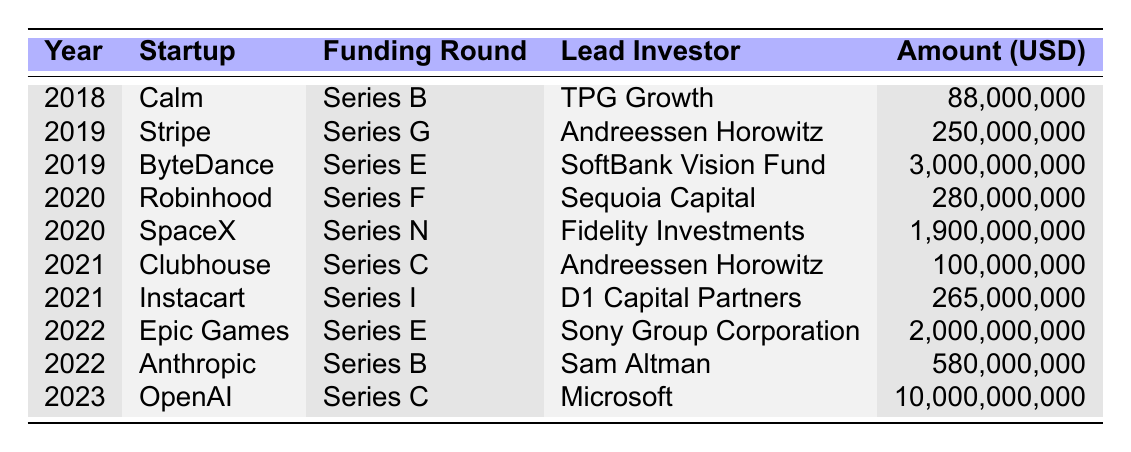What was the total funding amount raised by Stripe? According to the table, Stripe raised a total of $250,000,000 in its Series G funding round in 2019.
Answer: 250000000 Which startup received the highest funding amount? Looking at the table, OpenAI received the highest funding amount of $10,000,000,000 in its Series C round in 2023.
Answer: 10000000000 How many startups were funded in 2020? The table shows that Robinhood and SpaceX were funded in 2020, which makes a total of 2 startups.
Answer: 2 What is the average funding amount for the startups listed in 2019? The funding amounts for startups in 2019 are $250,000,000 (Stripe) and $3,000,000,000 (ByteDance). The total is $3,250,000,000, and with 2 startups, the average is $3,250,000,000 / 2 = $1,625,000,000.
Answer: 1625000000 Did Andreessen Horowitz invest in any startups in 2021? Yes, Andreessen Horowitz was the lead investor for Clubhouse in 2021, according to the table.
Answer: Yes How much more funding did SpaceX receive compared to Robinhood? SpaceX received $1,900,000,000, while Robinhood received $280,000,000. The difference is $1,900,000,000 - $280,000,000 = $1,620,000,000.
Answer: 1620000000 What percentage of the total funding received by Calm and Anthropic combined comes from Calm? Calm received $88,000,000 and Anthropic received $580,000,000. The combined funding is $88,000,000 + $580,000,000 = $668,000,000. The percentage from Calm is ($88,000,000 / $668,000,000) * 100 ≈ 13.16%.
Answer: 13.16 Which lead investor participated in the most funding rounds? The table shows that Andreessen Horowitz invested in two startups: Stripe and Clubhouse. Other investors each participated in only one. Thus, Andreessen Horowitz has the most participation.
Answer: Andreessen Horowitz How much funding was raised in 2022 compared to 2021? In 2022, Epic Games raised $2,000,000,000 and Anthropic raised $580,000,000, totaling $2,580,000,000. In 2021, Clubhouse raised $100,000,000 and Instacart raised $265,000,000, totaling $365,000,000. The difference is $2,580,000,000 - $365,000,000 = $2,215,000,000 raised in 2022 compared to 2021.
Answer: 2215000000 Which funding round had the most number of startups listed in the table? The table indicates that each funding round has only one startup except for Series B (Calm, Anthropic) and Series G (Stripe, ByteDance) which both comprise one startup each. Hence, no single funding round has more than one startup listed.
Answer: None 